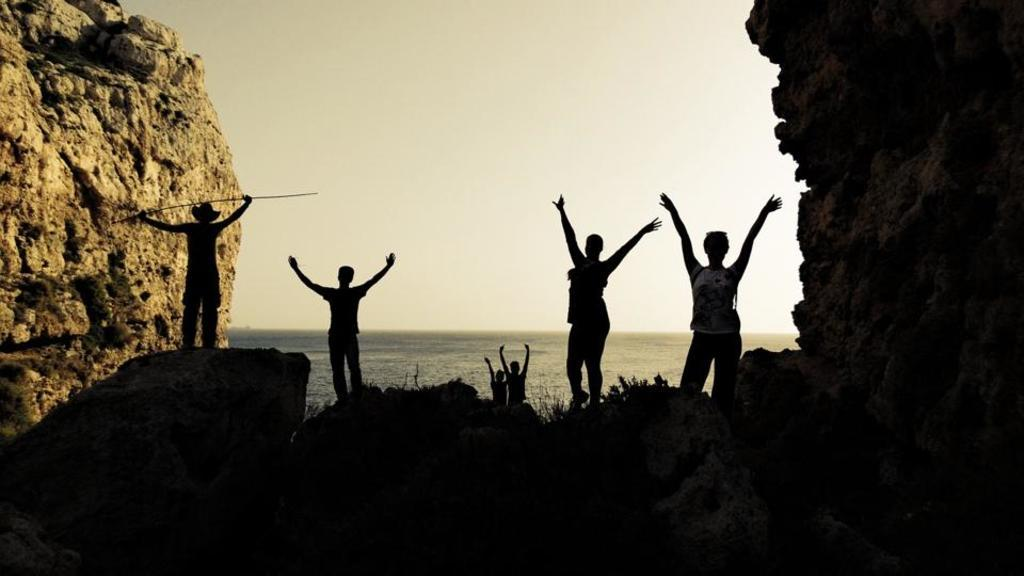What are the people in the image doing? The people in the image are standing on rocks. What is one person holding in the image? One person is holding a stick. What type of terrain is visible in the image? Rocks are present on both sides of the image. What can be seen in the background of the image? There is water and the sky visible in the background of the image. What type of food is being served during recess in the image? There is no mention of recess or food in the image; it features people standing on rocks with one person holding a stick. 